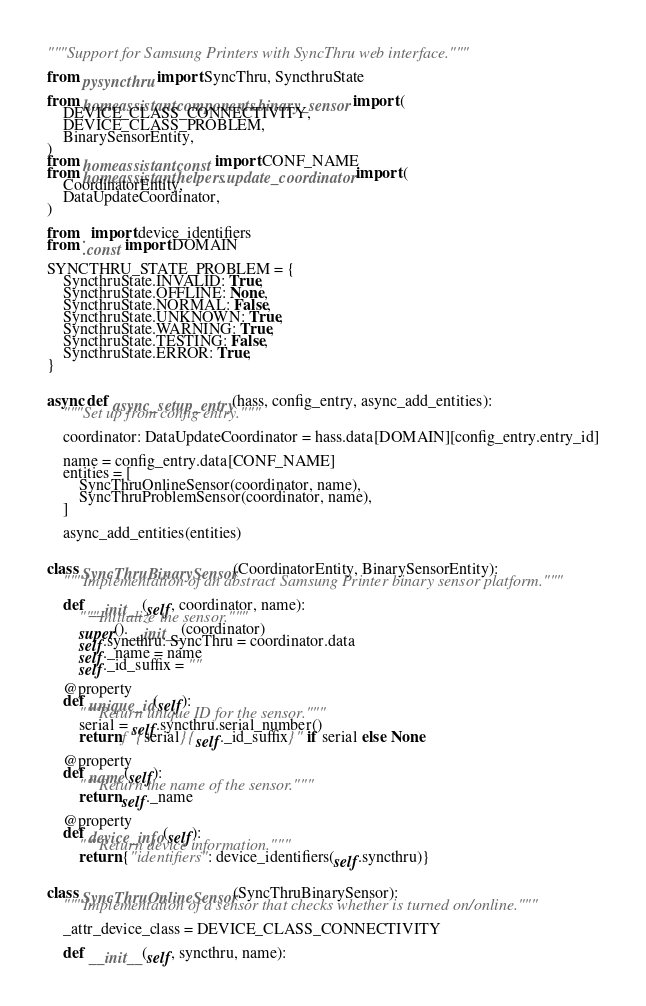Convert code to text. <code><loc_0><loc_0><loc_500><loc_500><_Python_>"""Support for Samsung Printers with SyncThru web interface."""

from pysyncthru import SyncThru, SyncthruState

from homeassistant.components.binary_sensor import (
    DEVICE_CLASS_CONNECTIVITY,
    DEVICE_CLASS_PROBLEM,
    BinarySensorEntity,
)
from homeassistant.const import CONF_NAME
from homeassistant.helpers.update_coordinator import (
    CoordinatorEntity,
    DataUpdateCoordinator,
)

from . import device_identifiers
from .const import DOMAIN

SYNCTHRU_STATE_PROBLEM = {
    SyncthruState.INVALID: True,
    SyncthruState.OFFLINE: None,
    SyncthruState.NORMAL: False,
    SyncthruState.UNKNOWN: True,
    SyncthruState.WARNING: True,
    SyncthruState.TESTING: False,
    SyncthruState.ERROR: True,
}


async def async_setup_entry(hass, config_entry, async_add_entities):
    """Set up from config entry."""

    coordinator: DataUpdateCoordinator = hass.data[DOMAIN][config_entry.entry_id]

    name = config_entry.data[CONF_NAME]
    entities = [
        SyncThruOnlineSensor(coordinator, name),
        SyncThruProblemSensor(coordinator, name),
    ]

    async_add_entities(entities)


class SyncThruBinarySensor(CoordinatorEntity, BinarySensorEntity):
    """Implementation of an abstract Samsung Printer binary sensor platform."""

    def __init__(self, coordinator, name):
        """Initialize the sensor."""
        super().__init__(coordinator)
        self.syncthru: SyncThru = coordinator.data
        self._name = name
        self._id_suffix = ""

    @property
    def unique_id(self):
        """Return unique ID for the sensor."""
        serial = self.syncthru.serial_number()
        return f"{serial}{self._id_suffix}" if serial else None

    @property
    def name(self):
        """Return the name of the sensor."""
        return self._name

    @property
    def device_info(self):
        """Return device information."""
        return {"identifiers": device_identifiers(self.syncthru)}


class SyncThruOnlineSensor(SyncThruBinarySensor):
    """Implementation of a sensor that checks whether is turned on/online."""

    _attr_device_class = DEVICE_CLASS_CONNECTIVITY

    def __init__(self, syncthru, name):</code> 